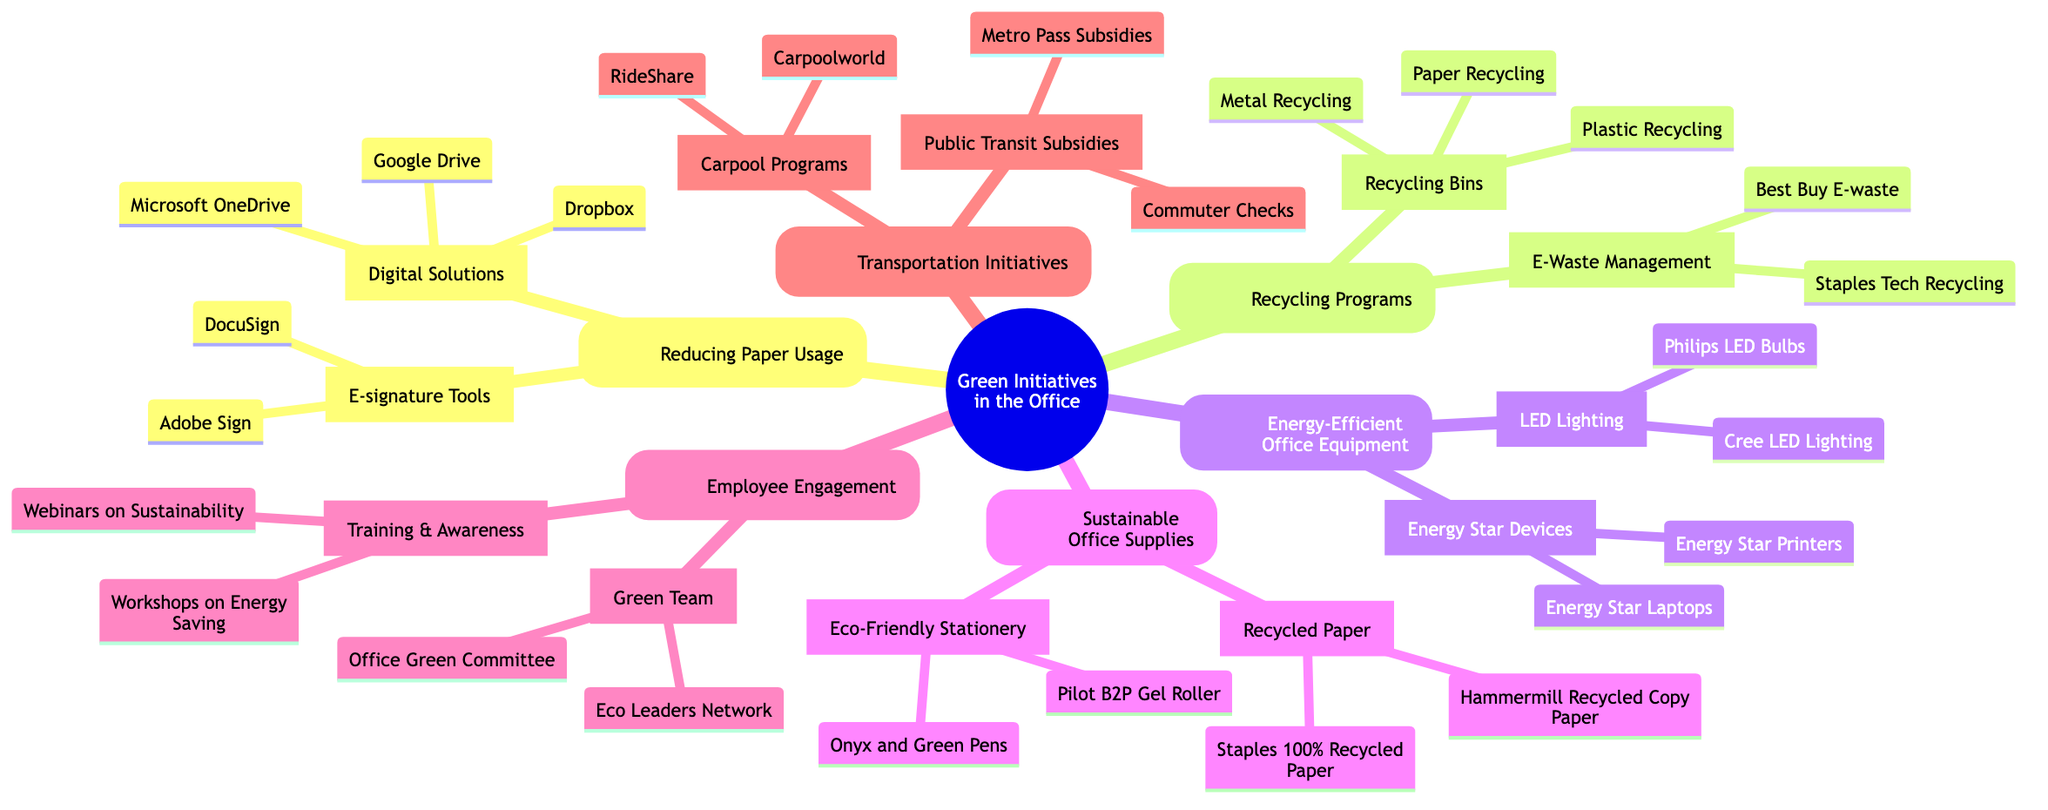What are two examples of Digital Solutions for reducing paper usage? The node labeled "Digital Solutions" under "Reducing Paper Usage" contains two examples: Google Drive and Microsoft OneDrive. These are the two items listed directly under this category.
Answer: Google Drive, Microsoft OneDrive How many types of Recycling Programs are listed in the diagram? The "Recycling Programs" node has two subcategories: "Recycling Bins" and "E-Waste Management." Counting these gives a total of 2 types of recycling programs.
Answer: 2 Which section of the mind map includes 'DocuSign'? "DocuSign" is found under the "E-signature Tools" subcategory, which is part of the "Reducing Paper Usage" section. This is determined by following the path from the root to these specific nodes.
Answer: E-signature Tools What type of employee engagement program is mentioned in the mind map? The "Employee Engagement" section has two programs listed, one being "Green Team" and the other "Training & Awareness." Thus, both programs reflect the types of engagement initiatives.
Answer: Green Team, Training & Awareness Which office equipment is categorized as Energy Star devices? Under the "Energy-Efficient Office Equipment" section, the subcategory "Energy Star Devices" lists examples including Energy Star Laptops and Energy Star Printers. Therefore, both of these are considered Energy Star devices.
Answer: Energy Star Laptops, Energy Star Printers How many types of transportation initiatives are mentioned in the map? In the "Transportation Initiatives" section, there are two subcategories: "Public Transit Subsidies" and "Carpool Programs." Counting these gives a total of 2 types of transportation initiatives.
Answer: 2 What is the purpose of the 'Green Team' in the office? "Green Team" is under the "Employee Engagement" section, indicating a focus on promoting environmental practices within the office, as it's aimed at increasing employee involvement in sustainability.
Answer: Promote environmental practices Which energy-efficient lighting options are presented in the diagram? The "LED Lighting" subcategory mentions Philips LED Bulbs and Cree LED Lighting, indicating these types of lighting as energy-efficient options available for the office.
Answer: Philips LED Bulbs, Cree LED Lighting What type of materials does the "Recycled Paper" category include? Under the "Sustainable Office Supplies" section, "Recycled Paper" includes items like Staples 100% Recycled Paper and Hammermill Recycled Copy Paper. Both items belong to this category.
Answer: Staples 100% Recycled Paper, Hammermill Recycled Copy Paper 